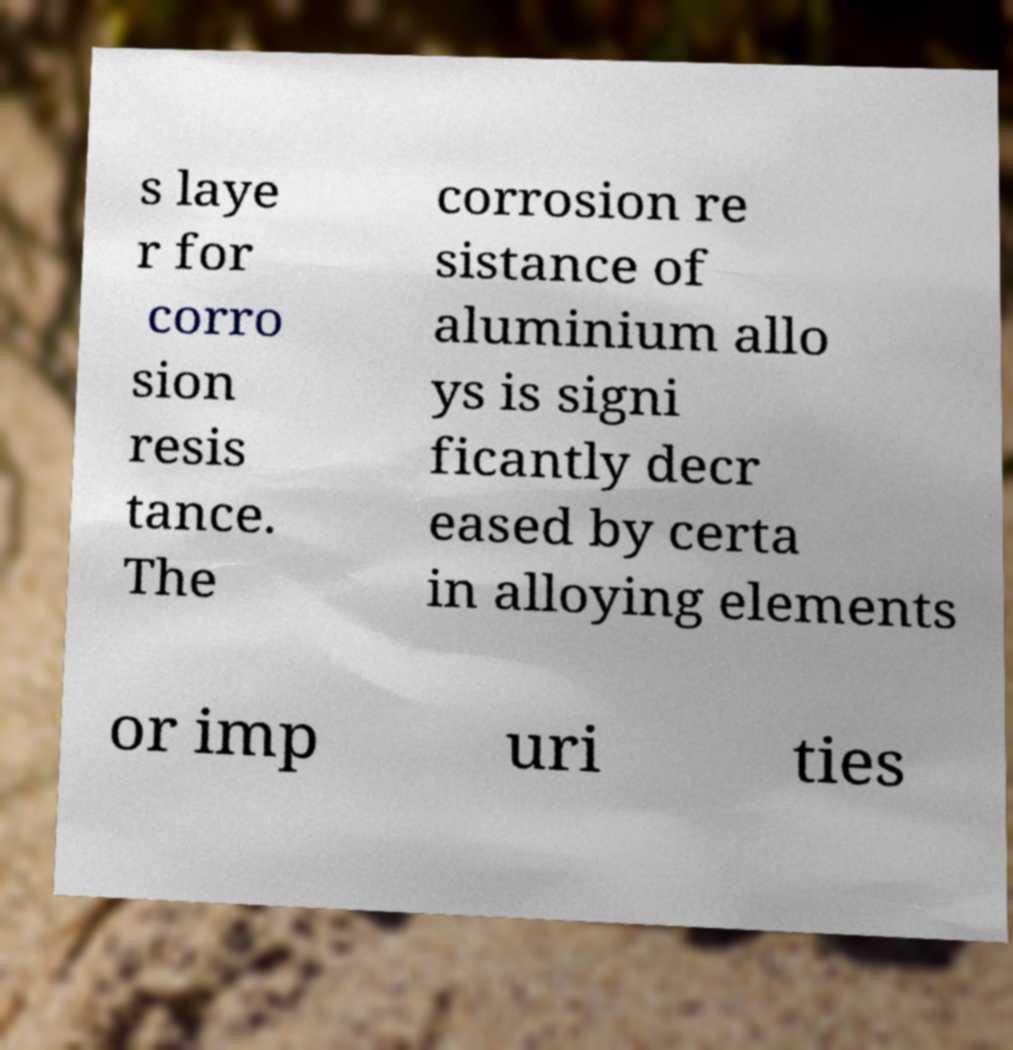I need the written content from this picture converted into text. Can you do that? s laye r for corro sion resis tance. The corrosion re sistance of aluminium allo ys is signi ficantly decr eased by certa in alloying elements or imp uri ties 